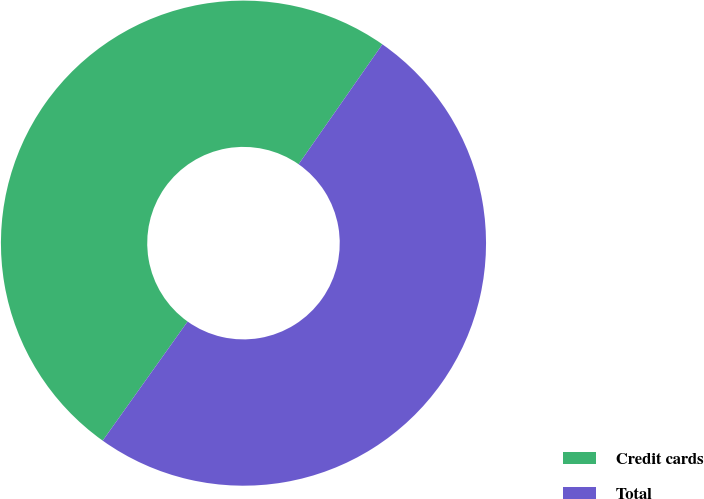<chart> <loc_0><loc_0><loc_500><loc_500><pie_chart><fcel>Credit cards<fcel>Total<nl><fcel>49.85%<fcel>50.15%<nl></chart> 